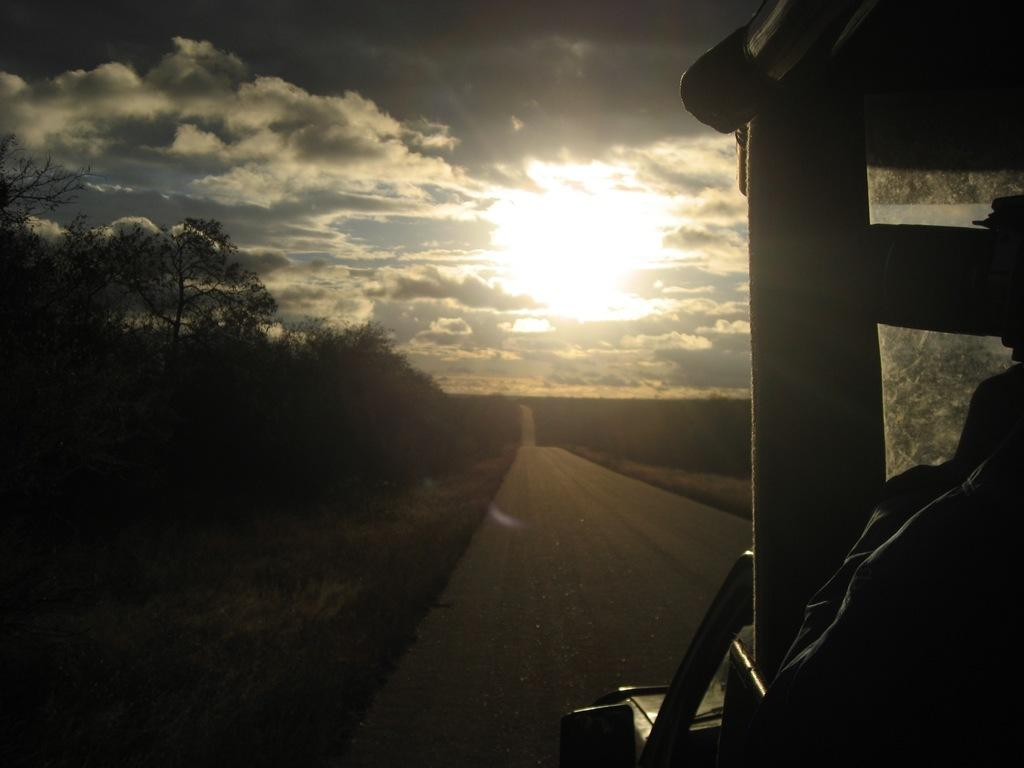What type of vegetation is present in the image? There are trees in the image. What type of surface can be seen in the image? There is a road in the image. What type of ground cover is visible in the image? There is grass in the image. What other objects can be seen in the image? There are other objects in the image. What is visible at the top of the image? The sky is visible at the top of the image. What type of vehicle can be seen on the right side of the image? There appears to be a vehicle on the right side of the image. Can you tell me how the baby is stretching in the image? There is no baby present in the image, so it is not possible to answer that question. 